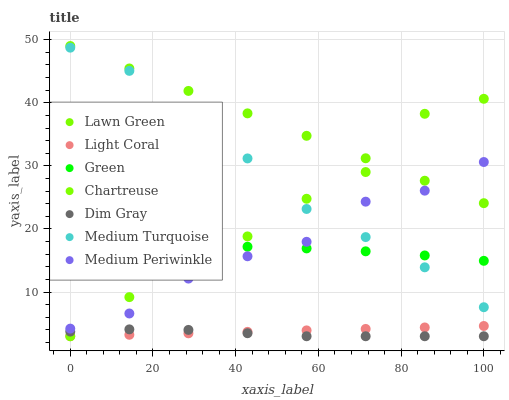Does Dim Gray have the minimum area under the curve?
Answer yes or no. Yes. Does Lawn Green have the maximum area under the curve?
Answer yes or no. Yes. Does Medium Periwinkle have the minimum area under the curve?
Answer yes or no. No. Does Medium Periwinkle have the maximum area under the curve?
Answer yes or no. No. Is Light Coral the smoothest?
Answer yes or no. Yes. Is Chartreuse the roughest?
Answer yes or no. Yes. Is Dim Gray the smoothest?
Answer yes or no. No. Is Dim Gray the roughest?
Answer yes or no. No. Does Dim Gray have the lowest value?
Answer yes or no. Yes. Does Medium Periwinkle have the lowest value?
Answer yes or no. No. Does Lawn Green have the highest value?
Answer yes or no. Yes. Does Medium Periwinkle have the highest value?
Answer yes or no. No. Is Dim Gray less than Medium Periwinkle?
Answer yes or no. Yes. Is Medium Periwinkle greater than Light Coral?
Answer yes or no. Yes. Does Lawn Green intersect Chartreuse?
Answer yes or no. Yes. Is Lawn Green less than Chartreuse?
Answer yes or no. No. Is Lawn Green greater than Chartreuse?
Answer yes or no. No. Does Dim Gray intersect Medium Periwinkle?
Answer yes or no. No. 